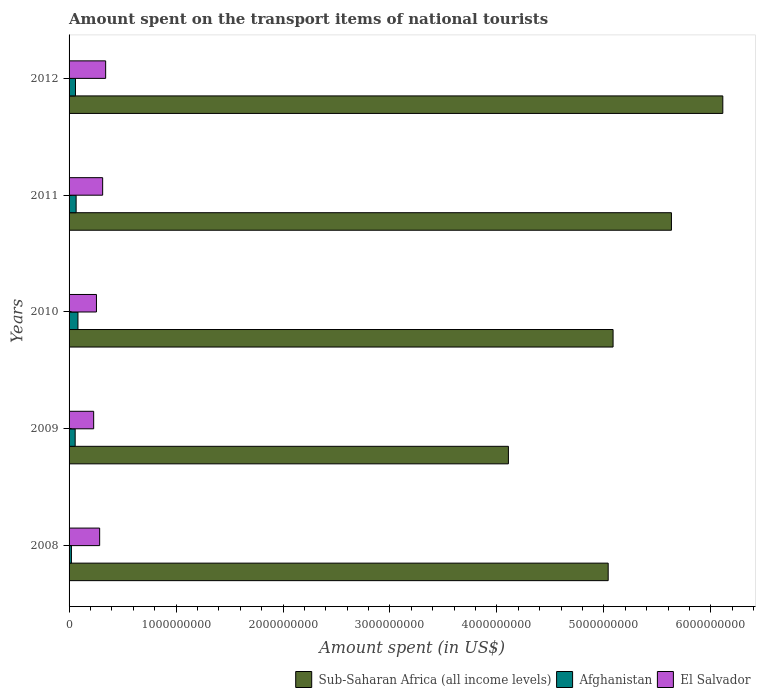Are the number of bars per tick equal to the number of legend labels?
Keep it short and to the point. Yes. Are the number of bars on each tick of the Y-axis equal?
Your answer should be very brief. Yes. What is the amount spent on the transport items of national tourists in Afghanistan in 2012?
Keep it short and to the point. 6.00e+07. Across all years, what is the maximum amount spent on the transport items of national tourists in Afghanistan?
Ensure brevity in your answer.  8.30e+07. Across all years, what is the minimum amount spent on the transport items of national tourists in Afghanistan?
Offer a very short reply. 2.20e+07. In which year was the amount spent on the transport items of national tourists in El Salvador maximum?
Make the answer very short. 2012. What is the total amount spent on the transport items of national tourists in Afghanistan in the graph?
Offer a terse response. 2.88e+08. What is the difference between the amount spent on the transport items of national tourists in Afghanistan in 2008 and that in 2009?
Your answer should be very brief. -3.50e+07. What is the difference between the amount spent on the transport items of national tourists in Sub-Saharan Africa (all income levels) in 2008 and the amount spent on the transport items of national tourists in El Salvador in 2012?
Your response must be concise. 4.70e+09. What is the average amount spent on the transport items of national tourists in Afghanistan per year?
Give a very brief answer. 5.76e+07. In the year 2010, what is the difference between the amount spent on the transport items of national tourists in Afghanistan and amount spent on the transport items of national tourists in El Salvador?
Make the answer very short. -1.73e+08. In how many years, is the amount spent on the transport items of national tourists in Afghanistan greater than 3000000000 US$?
Make the answer very short. 0. What is the ratio of the amount spent on the transport items of national tourists in Afghanistan in 2010 to that in 2011?
Your answer should be very brief. 1.26. What is the difference between the highest and the second highest amount spent on the transport items of national tourists in Sub-Saharan Africa (all income levels)?
Your response must be concise. 4.80e+08. What is the difference between the highest and the lowest amount spent on the transport items of national tourists in Sub-Saharan Africa (all income levels)?
Give a very brief answer. 2.00e+09. What does the 1st bar from the top in 2012 represents?
Ensure brevity in your answer.  El Salvador. What does the 2nd bar from the bottom in 2008 represents?
Offer a very short reply. Afghanistan. How many bars are there?
Ensure brevity in your answer.  15. How many years are there in the graph?
Make the answer very short. 5. What is the difference between two consecutive major ticks on the X-axis?
Offer a very short reply. 1.00e+09. Does the graph contain grids?
Make the answer very short. No. What is the title of the graph?
Offer a very short reply. Amount spent on the transport items of national tourists. Does "Australia" appear as one of the legend labels in the graph?
Your response must be concise. No. What is the label or title of the X-axis?
Offer a terse response. Amount spent (in US$). What is the label or title of the Y-axis?
Your response must be concise. Years. What is the Amount spent (in US$) in Sub-Saharan Africa (all income levels) in 2008?
Provide a succinct answer. 5.04e+09. What is the Amount spent (in US$) in Afghanistan in 2008?
Your answer should be compact. 2.20e+07. What is the Amount spent (in US$) of El Salvador in 2008?
Provide a succinct answer. 2.86e+08. What is the Amount spent (in US$) in Sub-Saharan Africa (all income levels) in 2009?
Make the answer very short. 4.11e+09. What is the Amount spent (in US$) in Afghanistan in 2009?
Give a very brief answer. 5.70e+07. What is the Amount spent (in US$) of El Salvador in 2009?
Your answer should be very brief. 2.30e+08. What is the Amount spent (in US$) of Sub-Saharan Africa (all income levels) in 2010?
Your answer should be very brief. 5.09e+09. What is the Amount spent (in US$) in Afghanistan in 2010?
Make the answer very short. 8.30e+07. What is the Amount spent (in US$) in El Salvador in 2010?
Your answer should be very brief. 2.56e+08. What is the Amount spent (in US$) of Sub-Saharan Africa (all income levels) in 2011?
Offer a very short reply. 5.63e+09. What is the Amount spent (in US$) in Afghanistan in 2011?
Offer a terse response. 6.60e+07. What is the Amount spent (in US$) in El Salvador in 2011?
Ensure brevity in your answer.  3.14e+08. What is the Amount spent (in US$) in Sub-Saharan Africa (all income levels) in 2012?
Your answer should be compact. 6.11e+09. What is the Amount spent (in US$) in Afghanistan in 2012?
Offer a terse response. 6.00e+07. What is the Amount spent (in US$) in El Salvador in 2012?
Give a very brief answer. 3.42e+08. Across all years, what is the maximum Amount spent (in US$) in Sub-Saharan Africa (all income levels)?
Offer a terse response. 6.11e+09. Across all years, what is the maximum Amount spent (in US$) of Afghanistan?
Make the answer very short. 8.30e+07. Across all years, what is the maximum Amount spent (in US$) of El Salvador?
Offer a terse response. 3.42e+08. Across all years, what is the minimum Amount spent (in US$) of Sub-Saharan Africa (all income levels)?
Offer a terse response. 4.11e+09. Across all years, what is the minimum Amount spent (in US$) in Afghanistan?
Your response must be concise. 2.20e+07. Across all years, what is the minimum Amount spent (in US$) of El Salvador?
Provide a succinct answer. 2.30e+08. What is the total Amount spent (in US$) in Sub-Saharan Africa (all income levels) in the graph?
Your answer should be compact. 2.60e+1. What is the total Amount spent (in US$) in Afghanistan in the graph?
Provide a succinct answer. 2.88e+08. What is the total Amount spent (in US$) in El Salvador in the graph?
Ensure brevity in your answer.  1.43e+09. What is the difference between the Amount spent (in US$) in Sub-Saharan Africa (all income levels) in 2008 and that in 2009?
Give a very brief answer. 9.33e+08. What is the difference between the Amount spent (in US$) in Afghanistan in 2008 and that in 2009?
Ensure brevity in your answer.  -3.50e+07. What is the difference between the Amount spent (in US$) in El Salvador in 2008 and that in 2009?
Keep it short and to the point. 5.60e+07. What is the difference between the Amount spent (in US$) in Sub-Saharan Africa (all income levels) in 2008 and that in 2010?
Provide a short and direct response. -4.57e+07. What is the difference between the Amount spent (in US$) in Afghanistan in 2008 and that in 2010?
Give a very brief answer. -6.10e+07. What is the difference between the Amount spent (in US$) in El Salvador in 2008 and that in 2010?
Make the answer very short. 3.00e+07. What is the difference between the Amount spent (in US$) in Sub-Saharan Africa (all income levels) in 2008 and that in 2011?
Make the answer very short. -5.91e+08. What is the difference between the Amount spent (in US$) of Afghanistan in 2008 and that in 2011?
Give a very brief answer. -4.40e+07. What is the difference between the Amount spent (in US$) in El Salvador in 2008 and that in 2011?
Provide a short and direct response. -2.80e+07. What is the difference between the Amount spent (in US$) of Sub-Saharan Africa (all income levels) in 2008 and that in 2012?
Your response must be concise. -1.07e+09. What is the difference between the Amount spent (in US$) of Afghanistan in 2008 and that in 2012?
Provide a succinct answer. -3.80e+07. What is the difference between the Amount spent (in US$) in El Salvador in 2008 and that in 2012?
Ensure brevity in your answer.  -5.60e+07. What is the difference between the Amount spent (in US$) in Sub-Saharan Africa (all income levels) in 2009 and that in 2010?
Offer a terse response. -9.79e+08. What is the difference between the Amount spent (in US$) of Afghanistan in 2009 and that in 2010?
Offer a very short reply. -2.60e+07. What is the difference between the Amount spent (in US$) of El Salvador in 2009 and that in 2010?
Your answer should be very brief. -2.60e+07. What is the difference between the Amount spent (in US$) of Sub-Saharan Africa (all income levels) in 2009 and that in 2011?
Offer a terse response. -1.52e+09. What is the difference between the Amount spent (in US$) of Afghanistan in 2009 and that in 2011?
Give a very brief answer. -9.00e+06. What is the difference between the Amount spent (in US$) of El Salvador in 2009 and that in 2011?
Keep it short and to the point. -8.40e+07. What is the difference between the Amount spent (in US$) of Sub-Saharan Africa (all income levels) in 2009 and that in 2012?
Keep it short and to the point. -2.00e+09. What is the difference between the Amount spent (in US$) of El Salvador in 2009 and that in 2012?
Keep it short and to the point. -1.12e+08. What is the difference between the Amount spent (in US$) of Sub-Saharan Africa (all income levels) in 2010 and that in 2011?
Give a very brief answer. -5.46e+08. What is the difference between the Amount spent (in US$) of Afghanistan in 2010 and that in 2011?
Provide a succinct answer. 1.70e+07. What is the difference between the Amount spent (in US$) in El Salvador in 2010 and that in 2011?
Your response must be concise. -5.80e+07. What is the difference between the Amount spent (in US$) in Sub-Saharan Africa (all income levels) in 2010 and that in 2012?
Ensure brevity in your answer.  -1.03e+09. What is the difference between the Amount spent (in US$) in Afghanistan in 2010 and that in 2012?
Your response must be concise. 2.30e+07. What is the difference between the Amount spent (in US$) of El Salvador in 2010 and that in 2012?
Your answer should be very brief. -8.60e+07. What is the difference between the Amount spent (in US$) in Sub-Saharan Africa (all income levels) in 2011 and that in 2012?
Provide a short and direct response. -4.80e+08. What is the difference between the Amount spent (in US$) in El Salvador in 2011 and that in 2012?
Make the answer very short. -2.80e+07. What is the difference between the Amount spent (in US$) of Sub-Saharan Africa (all income levels) in 2008 and the Amount spent (in US$) of Afghanistan in 2009?
Give a very brief answer. 4.98e+09. What is the difference between the Amount spent (in US$) of Sub-Saharan Africa (all income levels) in 2008 and the Amount spent (in US$) of El Salvador in 2009?
Ensure brevity in your answer.  4.81e+09. What is the difference between the Amount spent (in US$) in Afghanistan in 2008 and the Amount spent (in US$) in El Salvador in 2009?
Ensure brevity in your answer.  -2.08e+08. What is the difference between the Amount spent (in US$) of Sub-Saharan Africa (all income levels) in 2008 and the Amount spent (in US$) of Afghanistan in 2010?
Your response must be concise. 4.96e+09. What is the difference between the Amount spent (in US$) of Sub-Saharan Africa (all income levels) in 2008 and the Amount spent (in US$) of El Salvador in 2010?
Your response must be concise. 4.78e+09. What is the difference between the Amount spent (in US$) in Afghanistan in 2008 and the Amount spent (in US$) in El Salvador in 2010?
Provide a succinct answer. -2.34e+08. What is the difference between the Amount spent (in US$) of Sub-Saharan Africa (all income levels) in 2008 and the Amount spent (in US$) of Afghanistan in 2011?
Your answer should be compact. 4.97e+09. What is the difference between the Amount spent (in US$) of Sub-Saharan Africa (all income levels) in 2008 and the Amount spent (in US$) of El Salvador in 2011?
Provide a succinct answer. 4.73e+09. What is the difference between the Amount spent (in US$) of Afghanistan in 2008 and the Amount spent (in US$) of El Salvador in 2011?
Your response must be concise. -2.92e+08. What is the difference between the Amount spent (in US$) of Sub-Saharan Africa (all income levels) in 2008 and the Amount spent (in US$) of Afghanistan in 2012?
Your answer should be compact. 4.98e+09. What is the difference between the Amount spent (in US$) of Sub-Saharan Africa (all income levels) in 2008 and the Amount spent (in US$) of El Salvador in 2012?
Provide a succinct answer. 4.70e+09. What is the difference between the Amount spent (in US$) in Afghanistan in 2008 and the Amount spent (in US$) in El Salvador in 2012?
Your response must be concise. -3.20e+08. What is the difference between the Amount spent (in US$) in Sub-Saharan Africa (all income levels) in 2009 and the Amount spent (in US$) in Afghanistan in 2010?
Offer a terse response. 4.02e+09. What is the difference between the Amount spent (in US$) of Sub-Saharan Africa (all income levels) in 2009 and the Amount spent (in US$) of El Salvador in 2010?
Provide a short and direct response. 3.85e+09. What is the difference between the Amount spent (in US$) of Afghanistan in 2009 and the Amount spent (in US$) of El Salvador in 2010?
Give a very brief answer. -1.99e+08. What is the difference between the Amount spent (in US$) of Sub-Saharan Africa (all income levels) in 2009 and the Amount spent (in US$) of Afghanistan in 2011?
Your answer should be compact. 4.04e+09. What is the difference between the Amount spent (in US$) of Sub-Saharan Africa (all income levels) in 2009 and the Amount spent (in US$) of El Salvador in 2011?
Keep it short and to the point. 3.79e+09. What is the difference between the Amount spent (in US$) of Afghanistan in 2009 and the Amount spent (in US$) of El Salvador in 2011?
Offer a very short reply. -2.57e+08. What is the difference between the Amount spent (in US$) in Sub-Saharan Africa (all income levels) in 2009 and the Amount spent (in US$) in Afghanistan in 2012?
Provide a succinct answer. 4.05e+09. What is the difference between the Amount spent (in US$) in Sub-Saharan Africa (all income levels) in 2009 and the Amount spent (in US$) in El Salvador in 2012?
Your answer should be very brief. 3.77e+09. What is the difference between the Amount spent (in US$) of Afghanistan in 2009 and the Amount spent (in US$) of El Salvador in 2012?
Your answer should be very brief. -2.85e+08. What is the difference between the Amount spent (in US$) in Sub-Saharan Africa (all income levels) in 2010 and the Amount spent (in US$) in Afghanistan in 2011?
Your response must be concise. 5.02e+09. What is the difference between the Amount spent (in US$) of Sub-Saharan Africa (all income levels) in 2010 and the Amount spent (in US$) of El Salvador in 2011?
Your response must be concise. 4.77e+09. What is the difference between the Amount spent (in US$) of Afghanistan in 2010 and the Amount spent (in US$) of El Salvador in 2011?
Your answer should be compact. -2.31e+08. What is the difference between the Amount spent (in US$) in Sub-Saharan Africa (all income levels) in 2010 and the Amount spent (in US$) in Afghanistan in 2012?
Your response must be concise. 5.03e+09. What is the difference between the Amount spent (in US$) of Sub-Saharan Africa (all income levels) in 2010 and the Amount spent (in US$) of El Salvador in 2012?
Give a very brief answer. 4.74e+09. What is the difference between the Amount spent (in US$) of Afghanistan in 2010 and the Amount spent (in US$) of El Salvador in 2012?
Keep it short and to the point. -2.59e+08. What is the difference between the Amount spent (in US$) in Sub-Saharan Africa (all income levels) in 2011 and the Amount spent (in US$) in Afghanistan in 2012?
Offer a terse response. 5.57e+09. What is the difference between the Amount spent (in US$) of Sub-Saharan Africa (all income levels) in 2011 and the Amount spent (in US$) of El Salvador in 2012?
Your answer should be very brief. 5.29e+09. What is the difference between the Amount spent (in US$) of Afghanistan in 2011 and the Amount spent (in US$) of El Salvador in 2012?
Keep it short and to the point. -2.76e+08. What is the average Amount spent (in US$) in Sub-Saharan Africa (all income levels) per year?
Offer a terse response. 5.20e+09. What is the average Amount spent (in US$) of Afghanistan per year?
Give a very brief answer. 5.76e+07. What is the average Amount spent (in US$) of El Salvador per year?
Offer a very short reply. 2.86e+08. In the year 2008, what is the difference between the Amount spent (in US$) of Sub-Saharan Africa (all income levels) and Amount spent (in US$) of Afghanistan?
Your answer should be very brief. 5.02e+09. In the year 2008, what is the difference between the Amount spent (in US$) of Sub-Saharan Africa (all income levels) and Amount spent (in US$) of El Salvador?
Your answer should be very brief. 4.75e+09. In the year 2008, what is the difference between the Amount spent (in US$) in Afghanistan and Amount spent (in US$) in El Salvador?
Your response must be concise. -2.64e+08. In the year 2009, what is the difference between the Amount spent (in US$) in Sub-Saharan Africa (all income levels) and Amount spent (in US$) in Afghanistan?
Give a very brief answer. 4.05e+09. In the year 2009, what is the difference between the Amount spent (in US$) in Sub-Saharan Africa (all income levels) and Amount spent (in US$) in El Salvador?
Offer a very short reply. 3.88e+09. In the year 2009, what is the difference between the Amount spent (in US$) in Afghanistan and Amount spent (in US$) in El Salvador?
Ensure brevity in your answer.  -1.73e+08. In the year 2010, what is the difference between the Amount spent (in US$) in Sub-Saharan Africa (all income levels) and Amount spent (in US$) in Afghanistan?
Your answer should be compact. 5.00e+09. In the year 2010, what is the difference between the Amount spent (in US$) of Sub-Saharan Africa (all income levels) and Amount spent (in US$) of El Salvador?
Offer a terse response. 4.83e+09. In the year 2010, what is the difference between the Amount spent (in US$) of Afghanistan and Amount spent (in US$) of El Salvador?
Give a very brief answer. -1.73e+08. In the year 2011, what is the difference between the Amount spent (in US$) of Sub-Saharan Africa (all income levels) and Amount spent (in US$) of Afghanistan?
Provide a short and direct response. 5.57e+09. In the year 2011, what is the difference between the Amount spent (in US$) of Sub-Saharan Africa (all income levels) and Amount spent (in US$) of El Salvador?
Ensure brevity in your answer.  5.32e+09. In the year 2011, what is the difference between the Amount spent (in US$) in Afghanistan and Amount spent (in US$) in El Salvador?
Ensure brevity in your answer.  -2.48e+08. In the year 2012, what is the difference between the Amount spent (in US$) in Sub-Saharan Africa (all income levels) and Amount spent (in US$) in Afghanistan?
Your response must be concise. 6.05e+09. In the year 2012, what is the difference between the Amount spent (in US$) of Sub-Saharan Africa (all income levels) and Amount spent (in US$) of El Salvador?
Keep it short and to the point. 5.77e+09. In the year 2012, what is the difference between the Amount spent (in US$) of Afghanistan and Amount spent (in US$) of El Salvador?
Offer a terse response. -2.82e+08. What is the ratio of the Amount spent (in US$) in Sub-Saharan Africa (all income levels) in 2008 to that in 2009?
Provide a succinct answer. 1.23. What is the ratio of the Amount spent (in US$) of Afghanistan in 2008 to that in 2009?
Give a very brief answer. 0.39. What is the ratio of the Amount spent (in US$) in El Salvador in 2008 to that in 2009?
Keep it short and to the point. 1.24. What is the ratio of the Amount spent (in US$) of Sub-Saharan Africa (all income levels) in 2008 to that in 2010?
Provide a short and direct response. 0.99. What is the ratio of the Amount spent (in US$) in Afghanistan in 2008 to that in 2010?
Your response must be concise. 0.27. What is the ratio of the Amount spent (in US$) of El Salvador in 2008 to that in 2010?
Keep it short and to the point. 1.12. What is the ratio of the Amount spent (in US$) of Sub-Saharan Africa (all income levels) in 2008 to that in 2011?
Ensure brevity in your answer.  0.9. What is the ratio of the Amount spent (in US$) in Afghanistan in 2008 to that in 2011?
Keep it short and to the point. 0.33. What is the ratio of the Amount spent (in US$) in El Salvador in 2008 to that in 2011?
Your response must be concise. 0.91. What is the ratio of the Amount spent (in US$) in Sub-Saharan Africa (all income levels) in 2008 to that in 2012?
Offer a terse response. 0.82. What is the ratio of the Amount spent (in US$) in Afghanistan in 2008 to that in 2012?
Your answer should be very brief. 0.37. What is the ratio of the Amount spent (in US$) of El Salvador in 2008 to that in 2012?
Your answer should be very brief. 0.84. What is the ratio of the Amount spent (in US$) of Sub-Saharan Africa (all income levels) in 2009 to that in 2010?
Give a very brief answer. 0.81. What is the ratio of the Amount spent (in US$) of Afghanistan in 2009 to that in 2010?
Make the answer very short. 0.69. What is the ratio of the Amount spent (in US$) of El Salvador in 2009 to that in 2010?
Your response must be concise. 0.9. What is the ratio of the Amount spent (in US$) of Sub-Saharan Africa (all income levels) in 2009 to that in 2011?
Your response must be concise. 0.73. What is the ratio of the Amount spent (in US$) of Afghanistan in 2009 to that in 2011?
Keep it short and to the point. 0.86. What is the ratio of the Amount spent (in US$) in El Salvador in 2009 to that in 2011?
Your answer should be compact. 0.73. What is the ratio of the Amount spent (in US$) in Sub-Saharan Africa (all income levels) in 2009 to that in 2012?
Provide a succinct answer. 0.67. What is the ratio of the Amount spent (in US$) of El Salvador in 2009 to that in 2012?
Offer a terse response. 0.67. What is the ratio of the Amount spent (in US$) of Sub-Saharan Africa (all income levels) in 2010 to that in 2011?
Keep it short and to the point. 0.9. What is the ratio of the Amount spent (in US$) of Afghanistan in 2010 to that in 2011?
Ensure brevity in your answer.  1.26. What is the ratio of the Amount spent (in US$) of El Salvador in 2010 to that in 2011?
Provide a succinct answer. 0.82. What is the ratio of the Amount spent (in US$) in Sub-Saharan Africa (all income levels) in 2010 to that in 2012?
Make the answer very short. 0.83. What is the ratio of the Amount spent (in US$) of Afghanistan in 2010 to that in 2012?
Your response must be concise. 1.38. What is the ratio of the Amount spent (in US$) of El Salvador in 2010 to that in 2012?
Give a very brief answer. 0.75. What is the ratio of the Amount spent (in US$) of Sub-Saharan Africa (all income levels) in 2011 to that in 2012?
Offer a very short reply. 0.92. What is the ratio of the Amount spent (in US$) of Afghanistan in 2011 to that in 2012?
Your answer should be compact. 1.1. What is the ratio of the Amount spent (in US$) in El Salvador in 2011 to that in 2012?
Provide a succinct answer. 0.92. What is the difference between the highest and the second highest Amount spent (in US$) in Sub-Saharan Africa (all income levels)?
Provide a short and direct response. 4.80e+08. What is the difference between the highest and the second highest Amount spent (in US$) of Afghanistan?
Your answer should be very brief. 1.70e+07. What is the difference between the highest and the second highest Amount spent (in US$) in El Salvador?
Your answer should be compact. 2.80e+07. What is the difference between the highest and the lowest Amount spent (in US$) of Sub-Saharan Africa (all income levels)?
Provide a short and direct response. 2.00e+09. What is the difference between the highest and the lowest Amount spent (in US$) in Afghanistan?
Your response must be concise. 6.10e+07. What is the difference between the highest and the lowest Amount spent (in US$) of El Salvador?
Keep it short and to the point. 1.12e+08. 